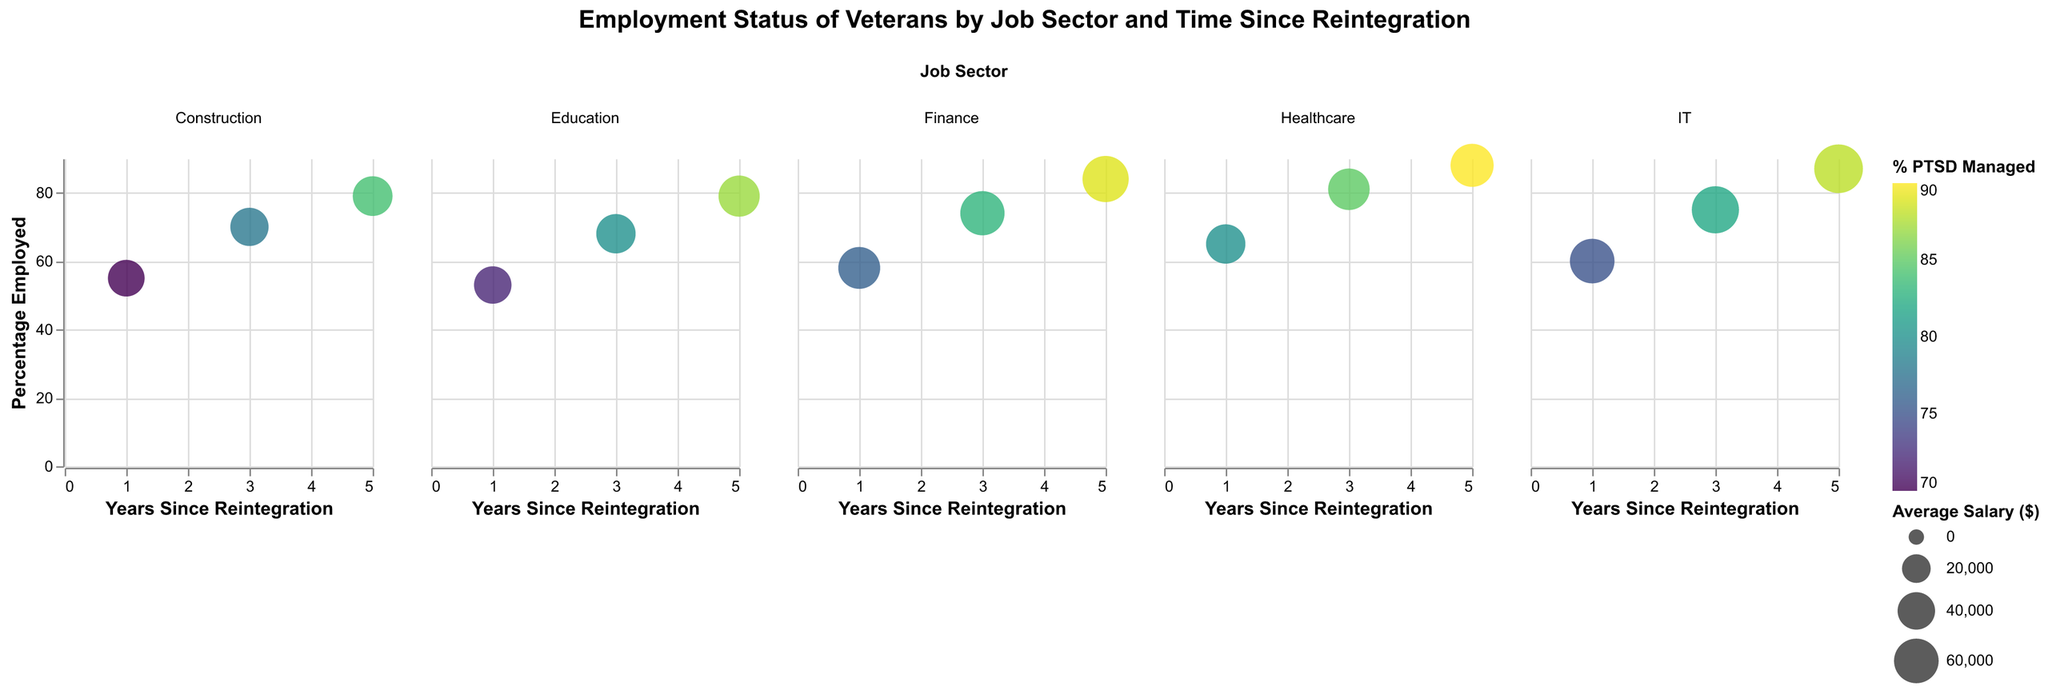What is the title of the plot? The title is located at the top center of the plot. It provides an overview of what the plot is about.
Answer: Employment Status of Veterans by Job Sector and Time Since Reintegration Which sector has the highest percentage employed for veterans reintegrated for 5 years? Look at the bubble plots for each sector at the 5-year mark on the x-axis and identify the bubble highest on the y-axis (Percentage Employed).
Answer: Healthcare What is the average salary of employed veterans in the IT sector at 3 years since reintegration? Locate the bubble in the IT sector subplot at the 3-year mark and check the tooltip or legend for the average salary.
Answer: $68,000 Compare the percentage of employed veterans between the Healthcare and Finance sectors at 1 year since reintegration. Which is higher? Find the bubbles representing 1 year on the x-axis under both Healthcare and Finance. Healthcare has a percentage of 65%, and Finance has a percentage of 58%.
Answer: Healthcare Which job sector shows the best management of PTSD (highest Percentage PTSD Managed) for employed veterans at the 5-year mark? Look for the bubble with the highest color intensity at the 5-year mark on the x-axis and check the legend for Percentage PTSD Managed.
Answer: Healthcare What's the difference in average salary between the Construction and Education sectors for employed veterans 3 years after reintegration? Locate the bubbles for each sector at the 3-year mark, note their average salaries, and subtract the smaller from the larger. Construction: $42,000, Education: $45,000. Difference = $45,000 - $42,000.
Answer: $3,000 What trend do you observe in the percentage of employed veterans in the Education sector over time? Look at the Education subplot and observe the position of bubbles on the y-axis over the 1, 3, and 5-year marks on the x-axis. The bubbles move higher over time.
Answer: Increasing How does the average salary in the Healthcare sector for employed veterans change over time since reintegration? In the Healthcare subplot, check the average salary for 1, 3, and 5 years since reintegration using the tooltip or size of the bubbles. The average salary increases over time.
Answer: Increases Which sector has the lowest percentage of employed veterans at the 1-year mark? Identify the bubble closest to the bottom of the y-axis at the 1-year mark across all sectors.
Answer: Education How do the employment percentages compare between IT and Construction sectors at 5 years since reintegration? Locate the bubbles for IT and Construction at the 5-year mark, compare their heights on the y-axis for Percentage Employed. IT: 87%, Construction: 79%.
Answer: IT is higher 